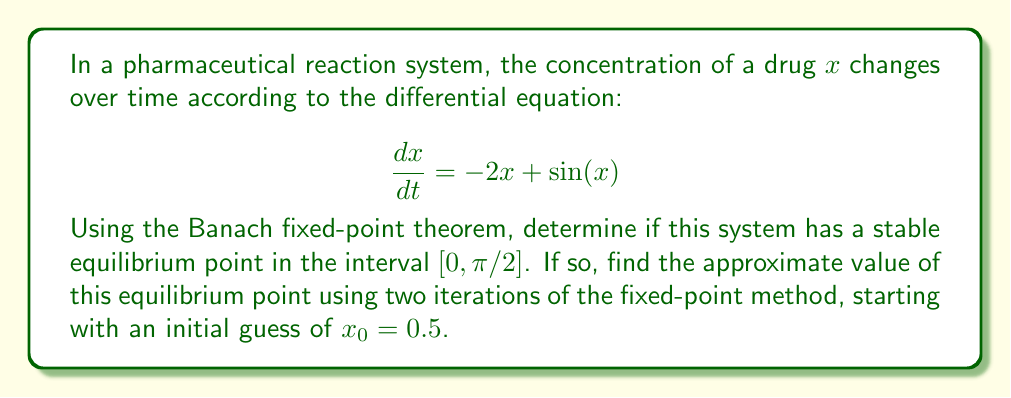Solve this math problem. 1. First, we need to rewrite the equation in the form $x = g(x)$ to apply the fixed-point theorem:

   $\frac{dx}{dt} = 0 = -2x + \sin(x)$
   $2x = \sin(x)$
   $x = \frac{1}{2}\sin(x)$

   So, $g(x) = \frac{1}{2}\sin(x)$

2. To apply the Banach fixed-point theorem, we need to show that $g(x)$ is a contraction mapping on $[0, \pi/2]$:

   $|g'(x)| = |\frac{1}{2}\cos(x)| \leq \frac{1}{2} < 1$ for all $x \in [0, \pi/2]$

   Since $|g'(x)| < 1$, $g(x)$ is a contraction mapping on $[0, \pi/2]$.

3. We also need to show that $g(x)$ maps $[0, \pi/2]$ into itself:

   $0 \leq \frac{1}{2}\sin(x) \leq \frac{1}{2}$ for all $x \in [0, \pi/2]$

   Therefore, $g(x)$ maps $[0, \pi/2]$ into itself.

4. By the Banach fixed-point theorem, there exists a unique fixed point in $[0, \pi/2]$, which is the stable equilibrium point.

5. To approximate the equilibrium point, we use the fixed-point iteration:

   $x_{n+1} = g(x_n) = \frac{1}{2}\sin(x_n)$

   Starting with $x_0 = 0.5$:

   $x_1 = \frac{1}{2}\sin(0.5) \approx 0.2397$
   $x_2 = \frac{1}{2}\sin(0.2397) \approx 0.1192$

Therefore, after two iterations, the approximate value of the equilibrium point is 0.1192.
Answer: Yes, stable equilibrium exists; $x \approx 0.1192$ 